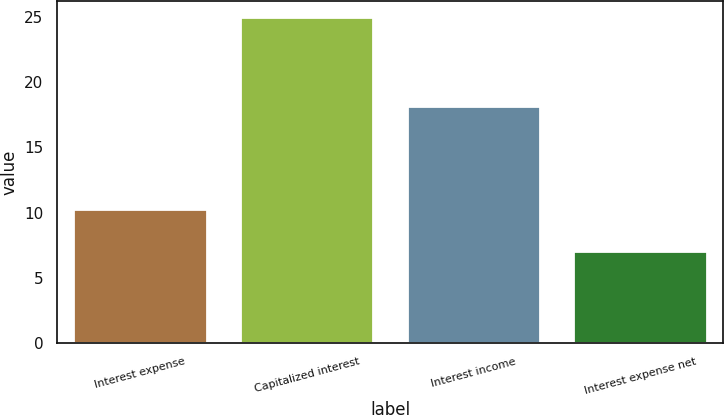Convert chart. <chart><loc_0><loc_0><loc_500><loc_500><bar_chart><fcel>Interest expense<fcel>Capitalized interest<fcel>Interest income<fcel>Interest expense net<nl><fcel>10.3<fcel>25<fcel>18.2<fcel>7.1<nl></chart> 